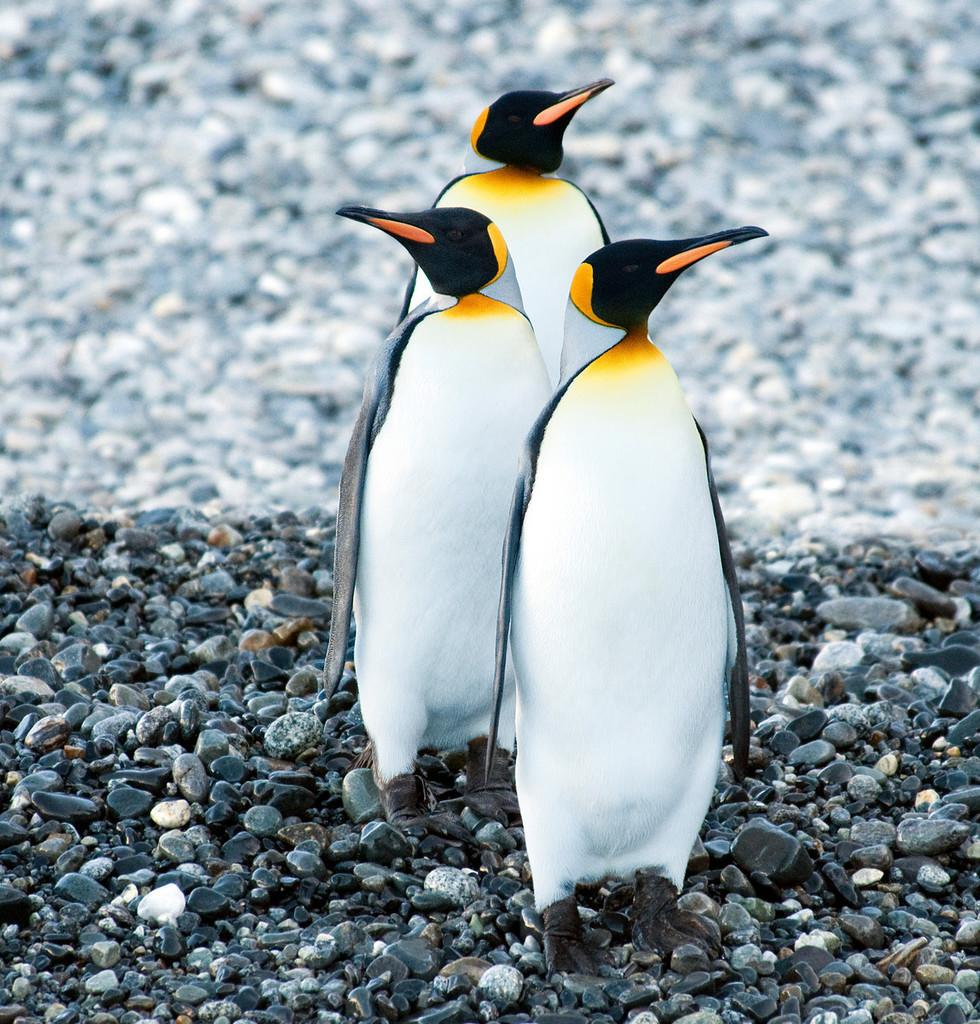What type of animals are present in the image? There are penguins in the image. What other objects can be seen in the image? There are stones in the image. Can you describe the background of the image? The background of the image is blurry. What color is the rose in the image? There is no rose present in the image. Is the gold object visible in the image? There is no gold object present in the image. 